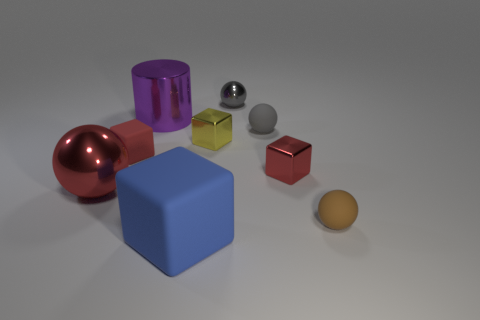Subtract all small red rubber blocks. How many blocks are left? 3 Add 1 large rubber cylinders. How many objects exist? 10 Subtract 3 balls. How many balls are left? 1 Subtract all blue cubes. How many yellow cylinders are left? 0 Subtract all yellow objects. Subtract all gray spheres. How many objects are left? 6 Add 4 blue rubber things. How many blue rubber things are left? 5 Add 8 big green metallic balls. How many big green metallic balls exist? 8 Subtract all red balls. How many balls are left? 3 Subtract 0 cyan blocks. How many objects are left? 9 Subtract all cylinders. How many objects are left? 8 